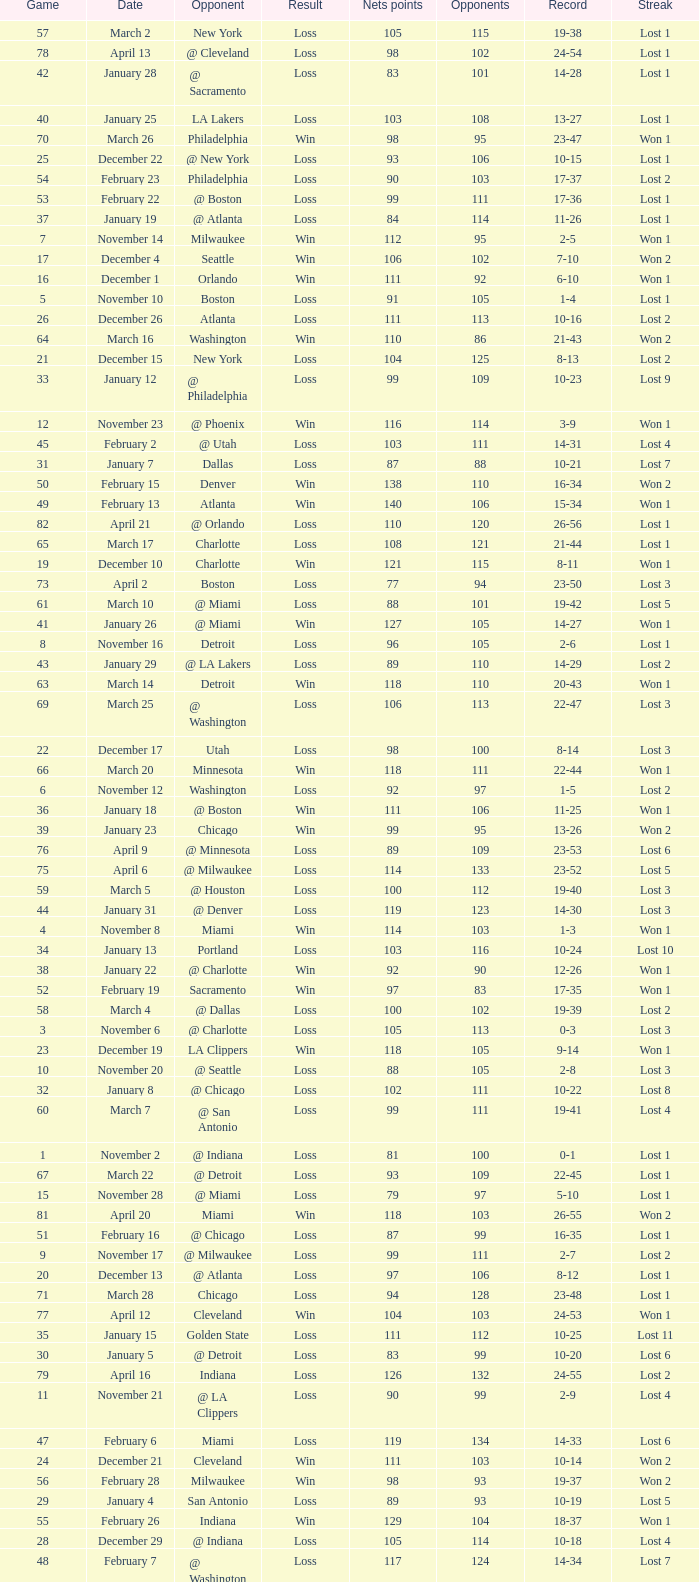What was the average point total for the nets in games before game 9 where the opponents scored less than 95? None. 